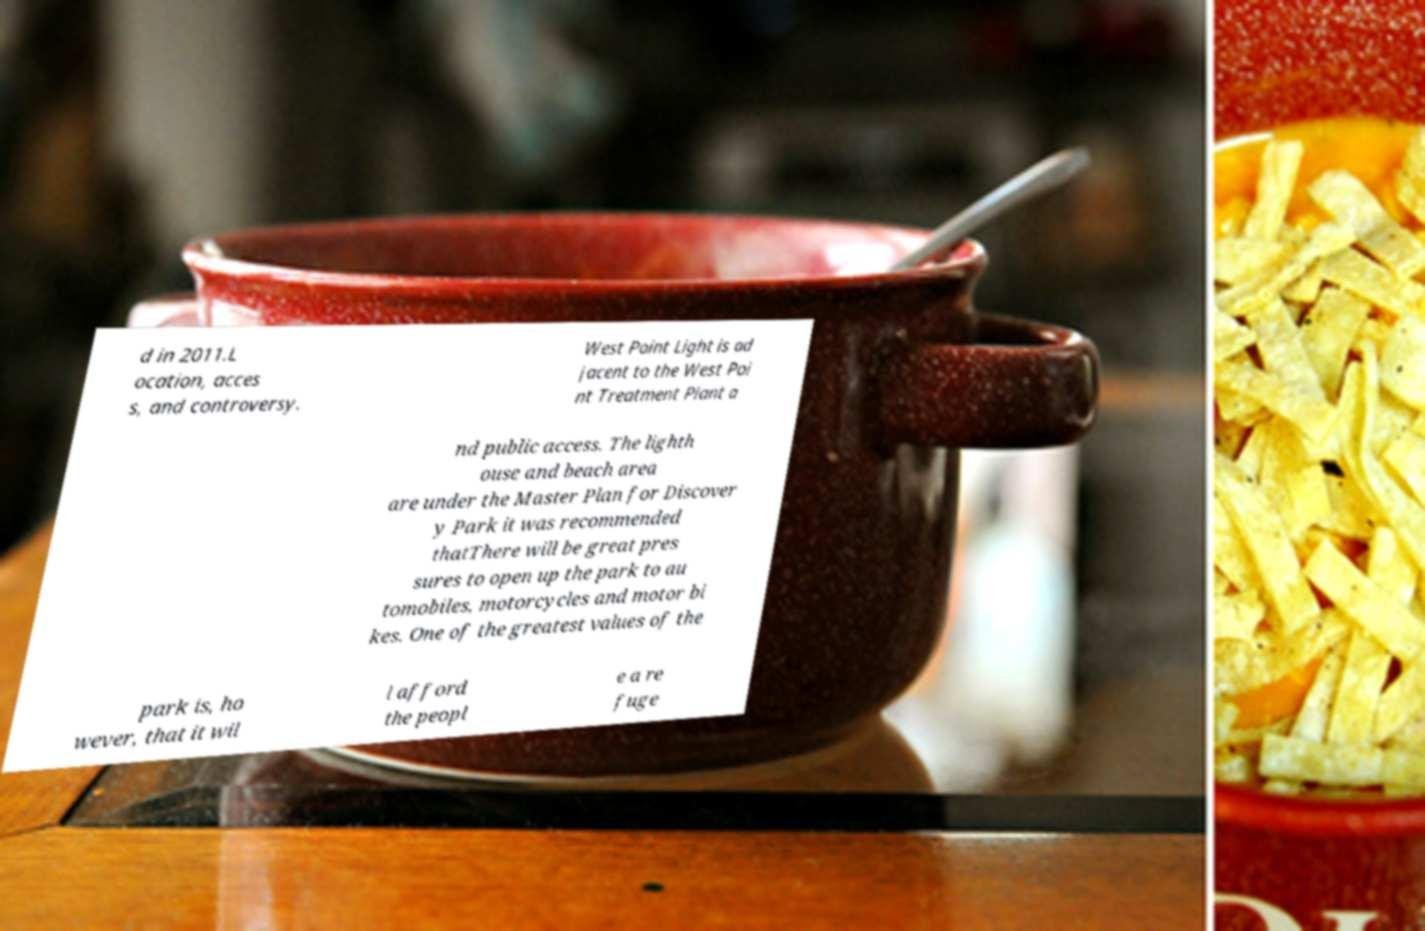Can you accurately transcribe the text from the provided image for me? d in 2011.L ocation, acces s, and controversy. West Point Light is ad jacent to the West Poi nt Treatment Plant a nd public access. The lighth ouse and beach area are under the Master Plan for Discover y Park it was recommended thatThere will be great pres sures to open up the park to au tomobiles, motorcycles and motor bi kes. One of the greatest values of the park is, ho wever, that it wil l afford the peopl e a re fuge 